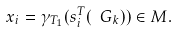Convert formula to latex. <formula><loc_0><loc_0><loc_500><loc_500>x _ { i } = \gamma _ { T _ { 1 } } ( s ^ { T } _ { i } ( \ G _ { k } ) ) \in M .</formula> 